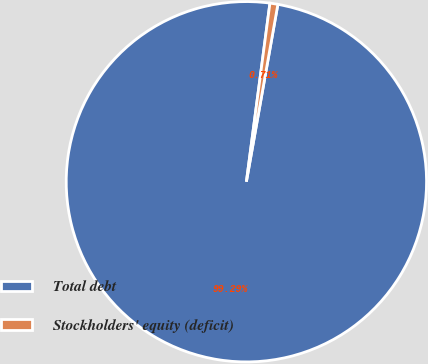Convert chart. <chart><loc_0><loc_0><loc_500><loc_500><pie_chart><fcel>Total debt<fcel>Stockholders' equity (deficit)<nl><fcel>99.29%<fcel>0.71%<nl></chart> 